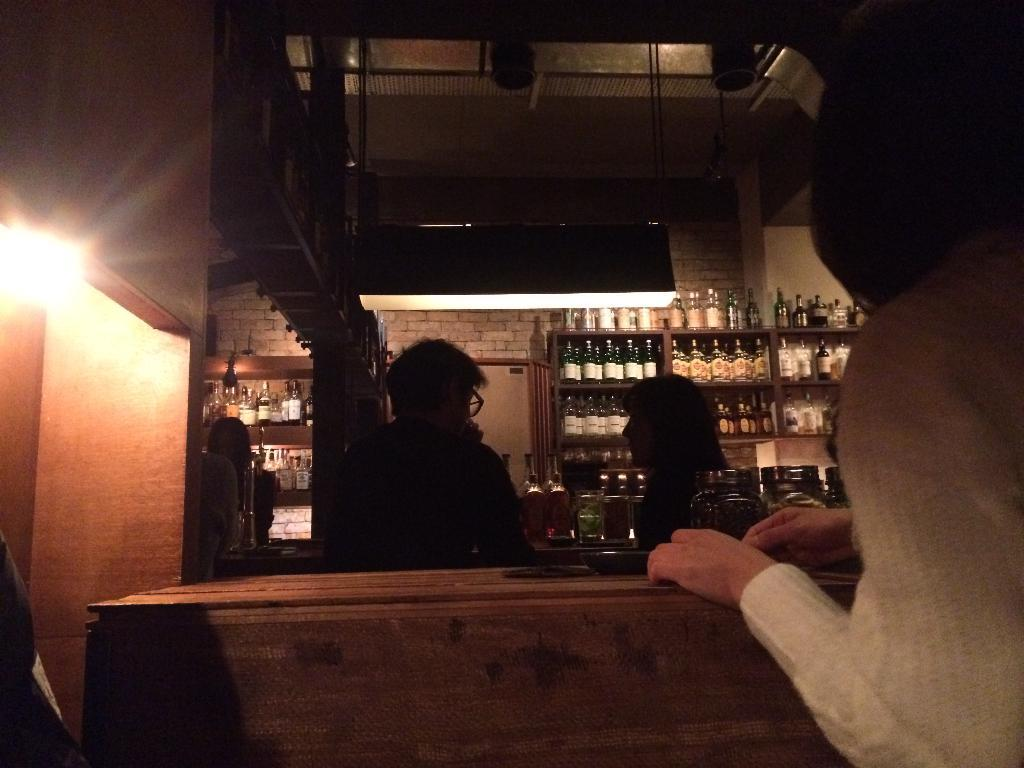Who or what can be seen in the image? There are persons in the image. What can be seen in the background of the image? There are bottles on shelves in the background. Where is the light located in the image? The light is on the left side of the image. What types of toys are the persons playing with in the image? There are no toys present in the image; it only shows persons and bottles on shelves in the background. 